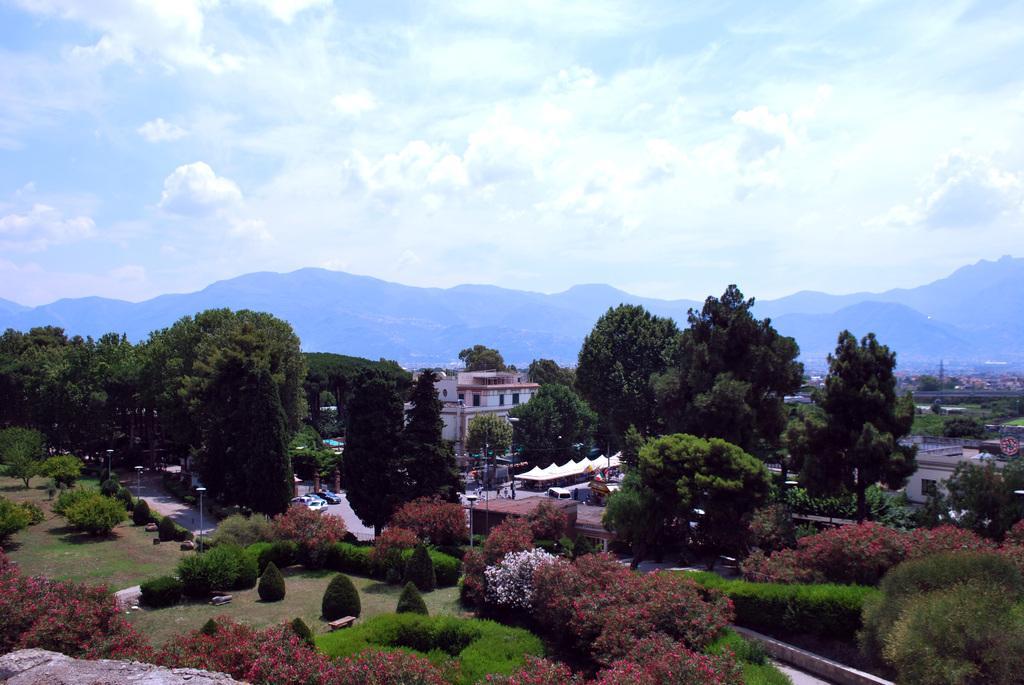Please provide a concise description of this image. In this image we can see an aerial view. In the aerial view there are buildings, street poles, street lights, bushes, trees, plants, roads, sheds, motor vehicles on the road, hills and sky with clouds. 